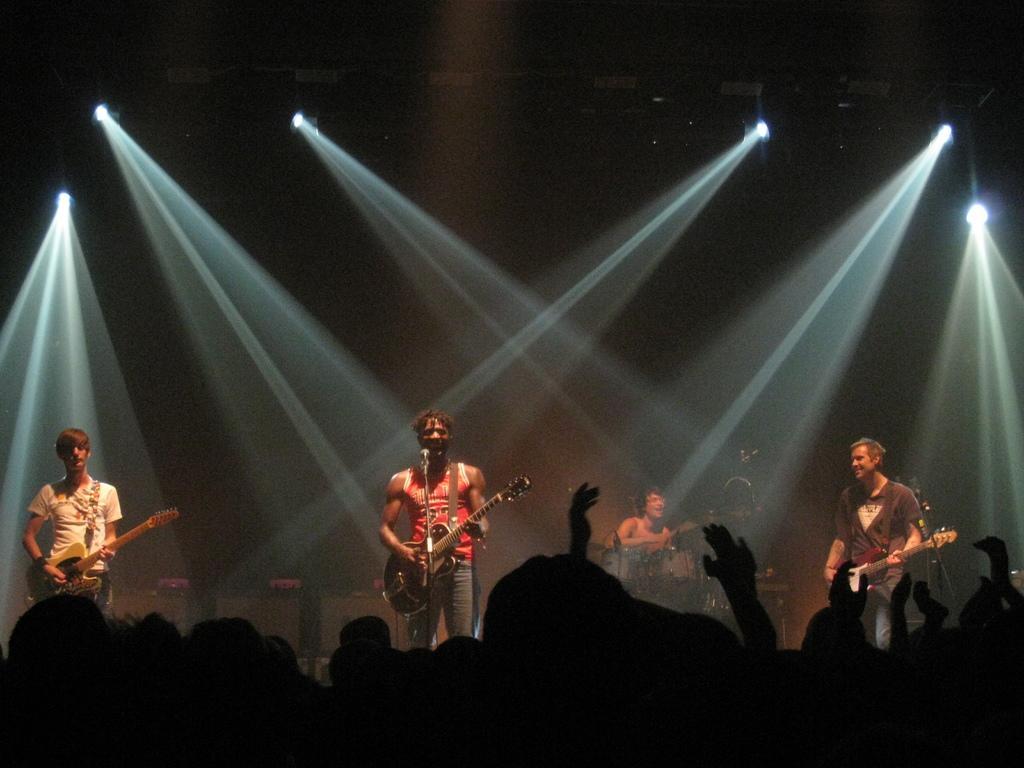Can you describe this image briefly? A rock band is performing in a concert. 